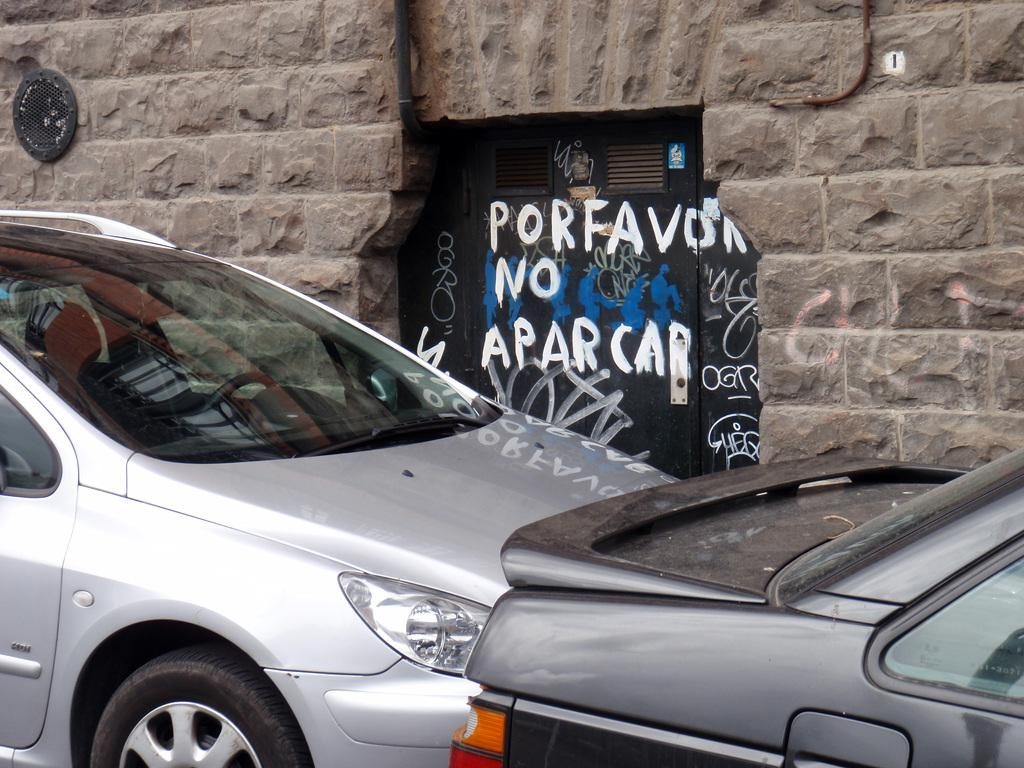What can be seen in the foreground of the image? There are cars in the foreground of the image. What is visible in the background of the image? There is a wall in the background of the image. Can you describe the wall in more detail? There is a door in the middle of the wall. What is written or depicted on the door? There are texts on the door. What type of pencil can be seen leaning against the wall in the image? There is no pencil present in the image. How does the love between the two people in the image manifest itself? There are no people or any indication of love in the image. 